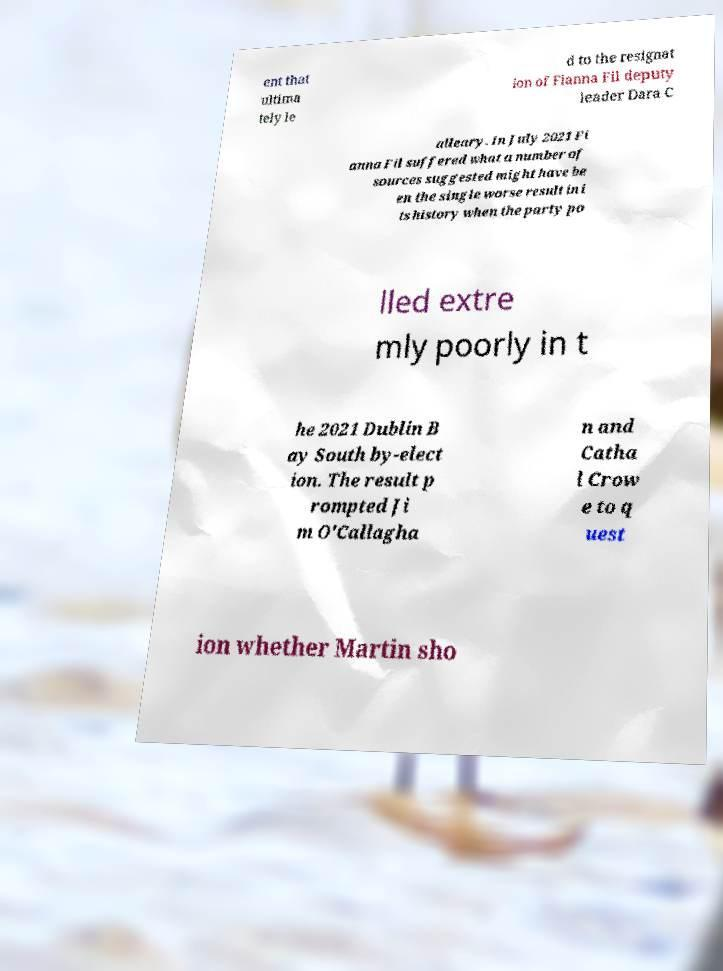Could you extract and type out the text from this image? ent that ultima tely le d to the resignat ion of Fianna Fil deputy leader Dara C alleary. In July 2021 Fi anna Fil suffered what a number of sources suggested might have be en the single worse result in i ts history when the party po lled extre mly poorly in t he 2021 Dublin B ay South by-elect ion. The result p rompted Ji m O'Callagha n and Catha l Crow e to q uest ion whether Martin sho 